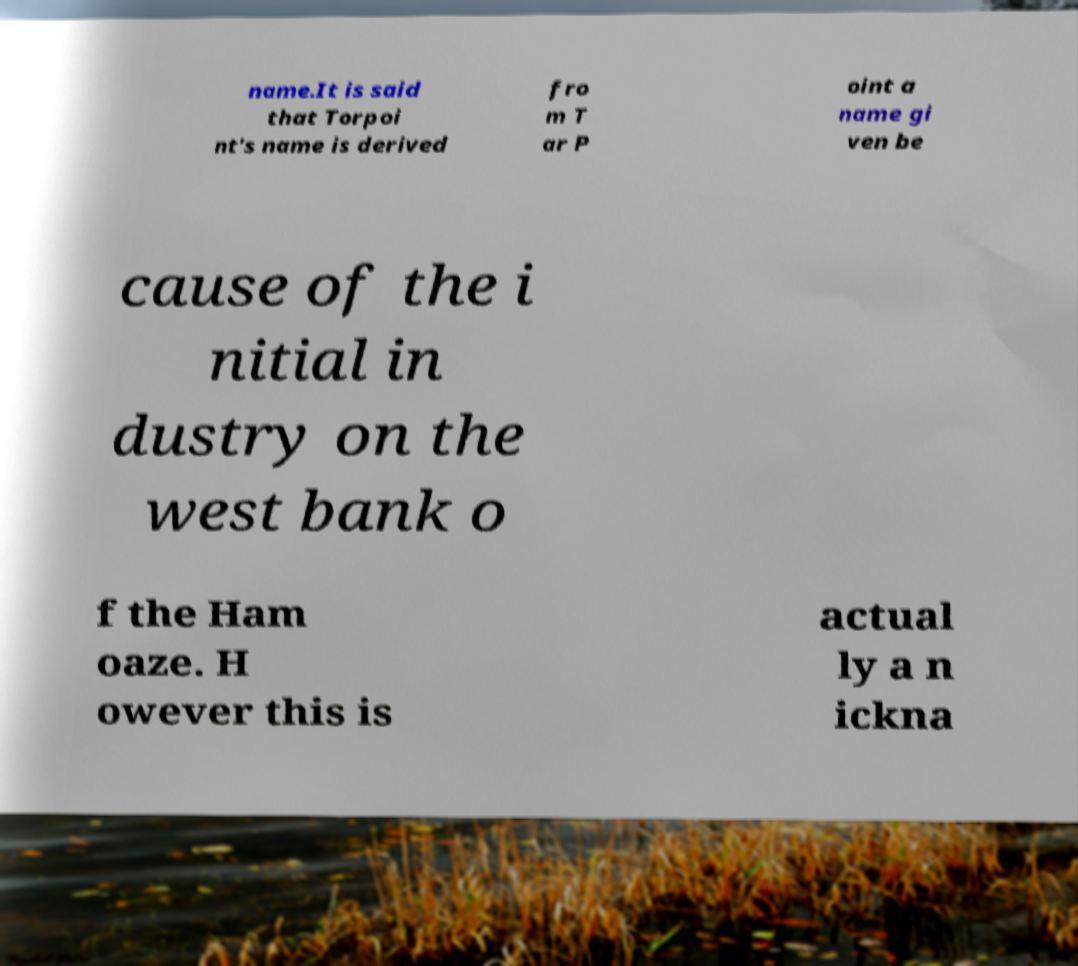Can you read and provide the text displayed in the image?This photo seems to have some interesting text. Can you extract and type it out for me? name.It is said that Torpoi nt's name is derived fro m T ar P oint a name gi ven be cause of the i nitial in dustry on the west bank o f the Ham oaze. H owever this is actual ly a n ickna 